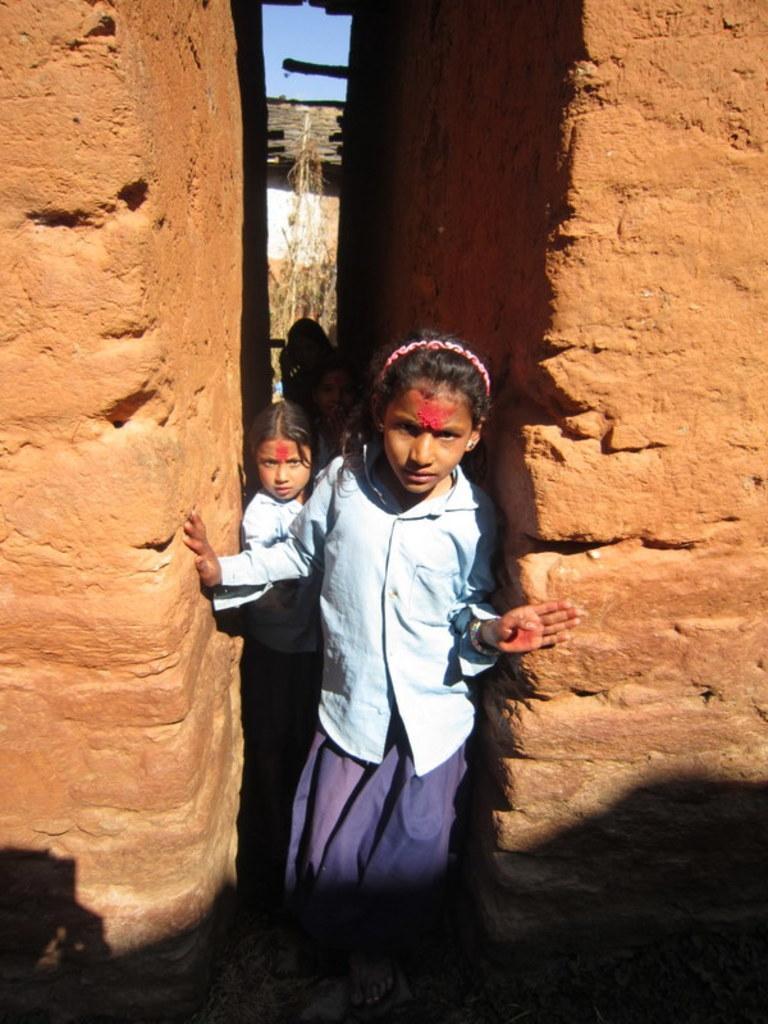Could you give a brief overview of what you see in this image? In the image we can see there are two girls standing in between the two buildings. The buildings are made up of red bricks. 